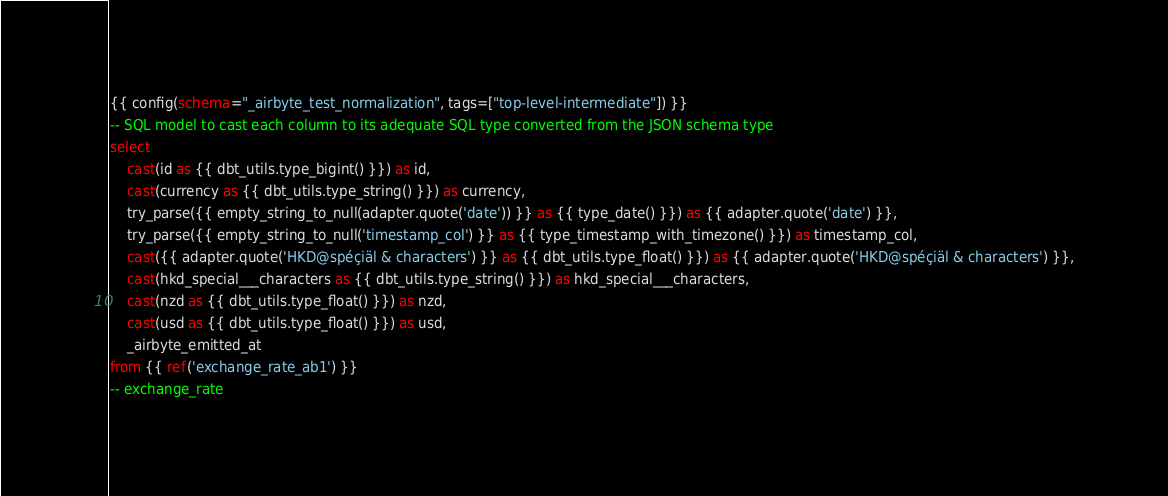<code> <loc_0><loc_0><loc_500><loc_500><_SQL_>{{ config(schema="_airbyte_test_normalization", tags=["top-level-intermediate"]) }}
-- SQL model to cast each column to its adequate SQL type converted from the JSON schema type
select
    cast(id as {{ dbt_utils.type_bigint() }}) as id,
    cast(currency as {{ dbt_utils.type_string() }}) as currency,
    try_parse({{ empty_string_to_null(adapter.quote('date')) }} as {{ type_date() }}) as {{ adapter.quote('date') }},
    try_parse({{ empty_string_to_null('timestamp_col') }} as {{ type_timestamp_with_timezone() }}) as timestamp_col,
    cast({{ adapter.quote('HKD@spéçiäl & characters') }} as {{ dbt_utils.type_float() }}) as {{ adapter.quote('HKD@spéçiäl & characters') }},
    cast(hkd_special___characters as {{ dbt_utils.type_string() }}) as hkd_special___characters,
    cast(nzd as {{ dbt_utils.type_float() }}) as nzd,
    cast(usd as {{ dbt_utils.type_float() }}) as usd,
    _airbyte_emitted_at
from {{ ref('exchange_rate_ab1') }}
-- exchange_rate

</code> 